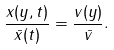<formula> <loc_0><loc_0><loc_500><loc_500>\frac { x ( y , t ) } { \bar { x } ( t ) } = \frac { v ( y ) } { \bar { v } } .</formula> 